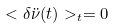Convert formula to latex. <formula><loc_0><loc_0><loc_500><loc_500>< \delta \ddot { \nu } ( t ) > _ { t } = 0</formula> 